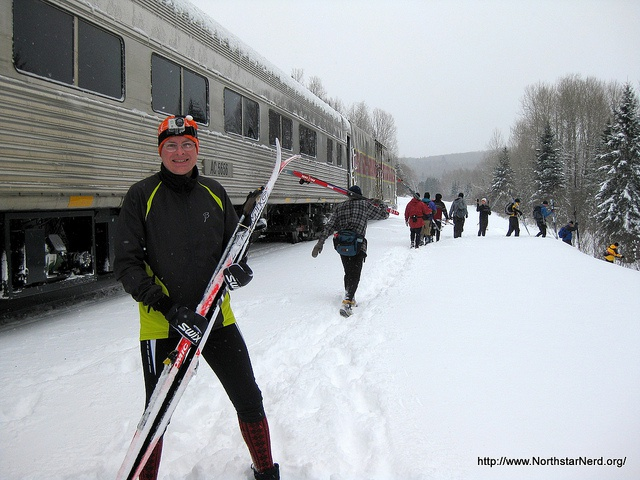Describe the objects in this image and their specific colors. I can see train in gray, darkgray, and black tones, people in gray, black, olive, and brown tones, skis in gray, black, lightgray, and darkgray tones, people in gray, black, darkblue, and darkgray tones, and people in gray, maroon, black, and brown tones in this image. 